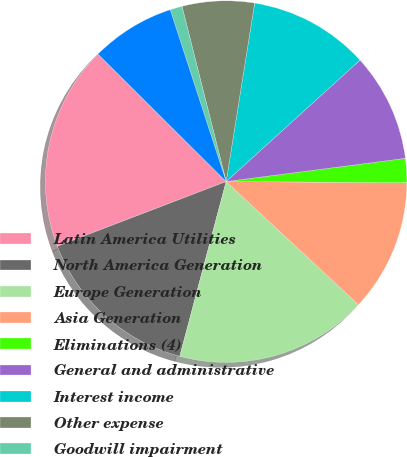Convert chart. <chart><loc_0><loc_0><loc_500><loc_500><pie_chart><fcel>Latin America Utilities<fcel>North America Generation<fcel>Europe Generation<fcel>Asia Generation<fcel>Eliminations (4)<fcel>General and administrative<fcel>Interest income<fcel>Other expense<fcel>Goodwill impairment<fcel>Asset impairment expense<nl><fcel>18.28%<fcel>15.05%<fcel>17.2%<fcel>11.83%<fcel>2.15%<fcel>9.68%<fcel>10.75%<fcel>6.45%<fcel>1.08%<fcel>7.53%<nl></chart> 